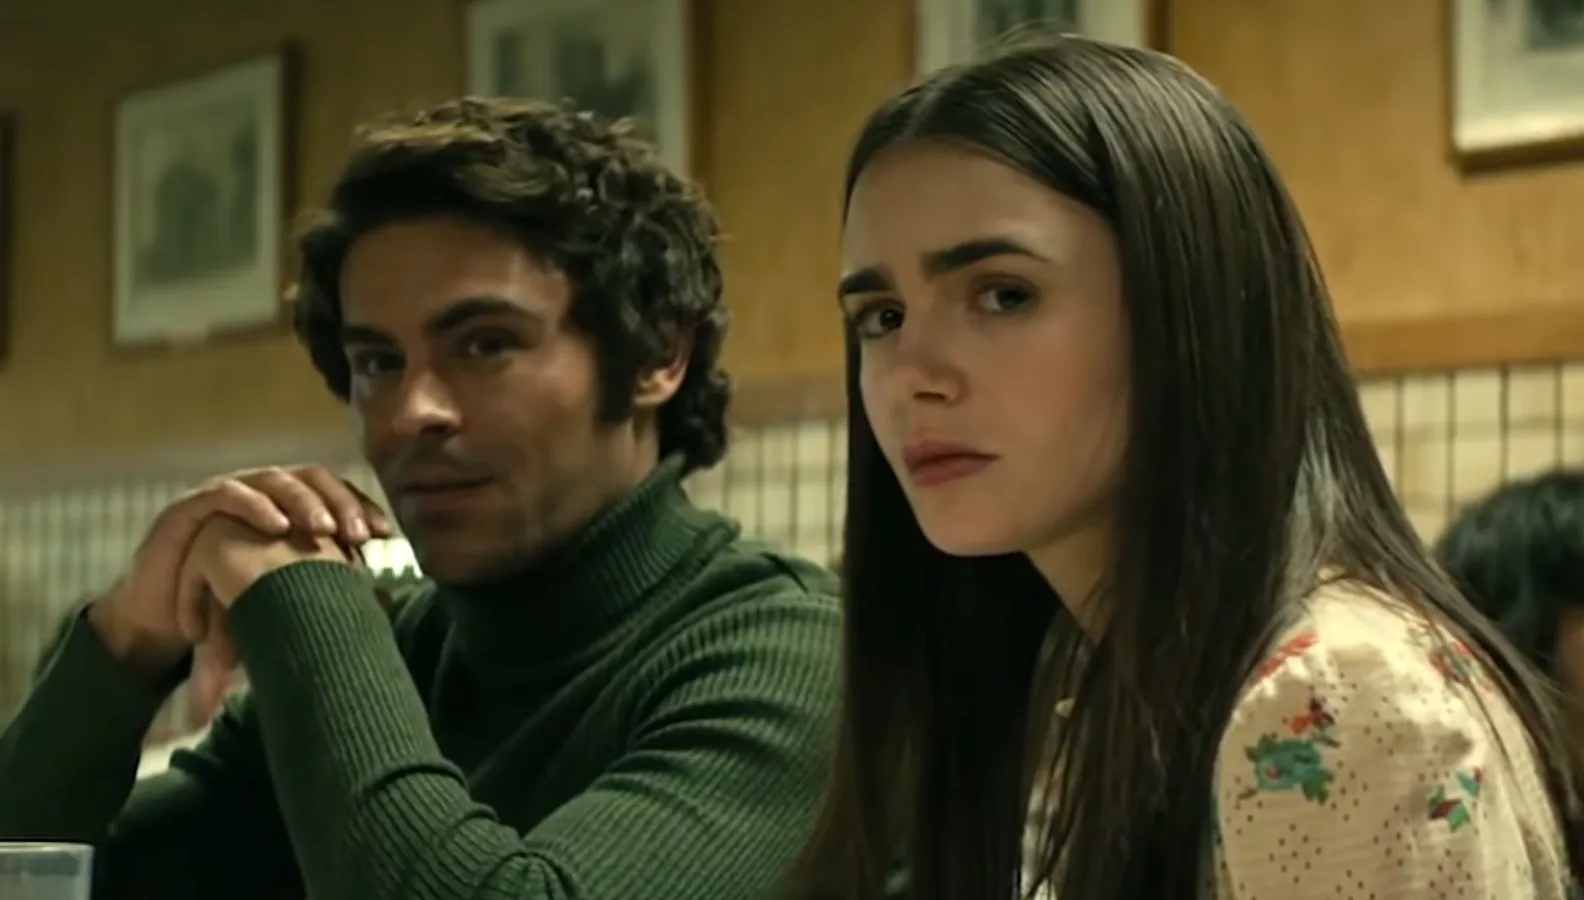What do the decor and elements in the diner signify about its history? The decor in the diner suggests a rich history, possibly dating back to the mid-20th century. The checkered wall design is indicative of a period style, lending a sense of nostalgia and timelessness. The framed pictures, which likely capture historical moments or local history, point towards a community-centered establishment, a place that has seen many stories unfold over decades. The overall ambiance hints at a time when diners were central to social life, a welcoming hub for both everyday encounters and significant conversations, much like the one depicted in the image. 